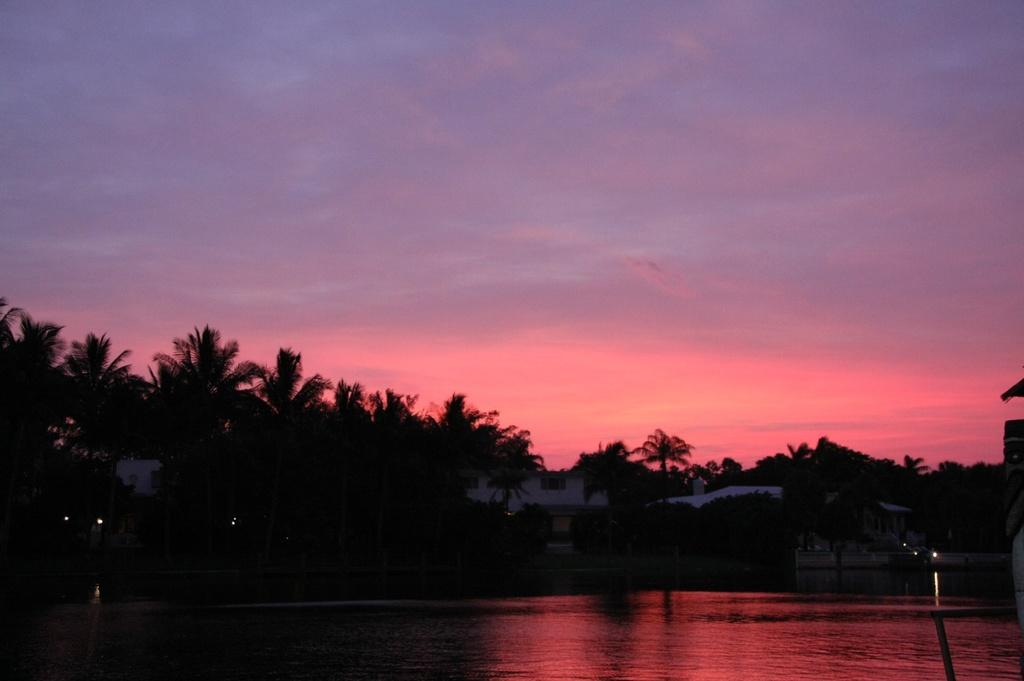What type of natural elements can be seen in the image? There are trees in the image. What type of man-made structures are present in the image? There are buildings in the image. What type of illumination is visible in the image? There are lights in the image. What can be seen at the top of the image? Water and the sky are visible at the top of the image. What type of cracker is being used as a decoration on the shoe in the image? There is no shoe or cracker present in the image. What type of dinner is being served in the image? There is no dinner or reference to food in the image. 